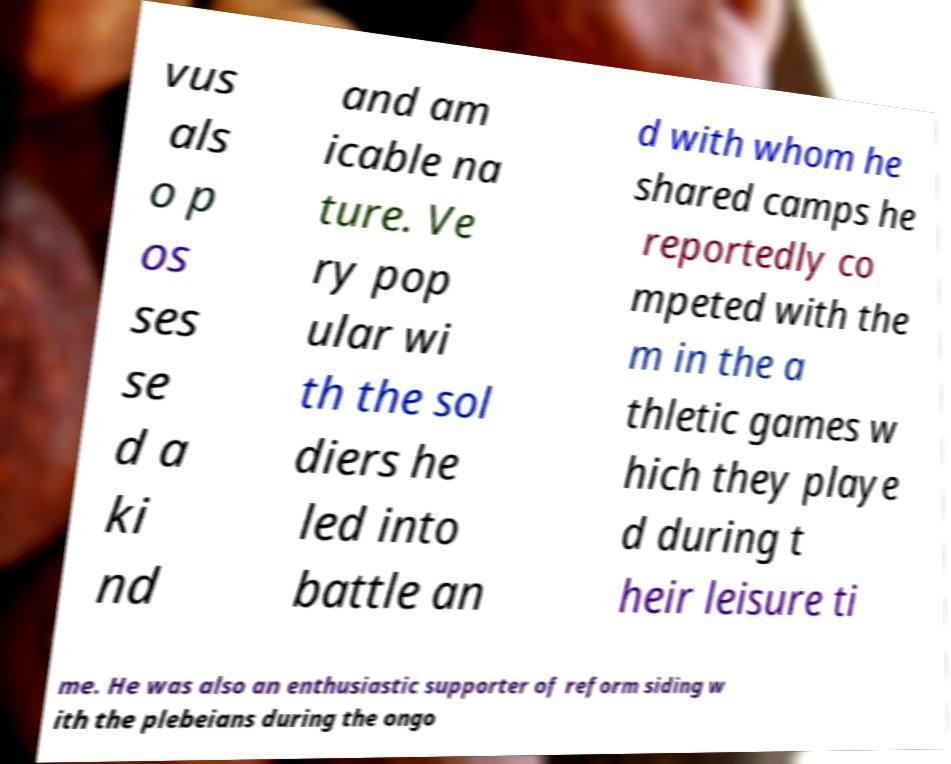There's text embedded in this image that I need extracted. Can you transcribe it verbatim? vus als o p os ses se d a ki nd and am icable na ture. Ve ry pop ular wi th the sol diers he led into battle an d with whom he shared camps he reportedly co mpeted with the m in the a thletic games w hich they playe d during t heir leisure ti me. He was also an enthusiastic supporter of reform siding w ith the plebeians during the ongo 